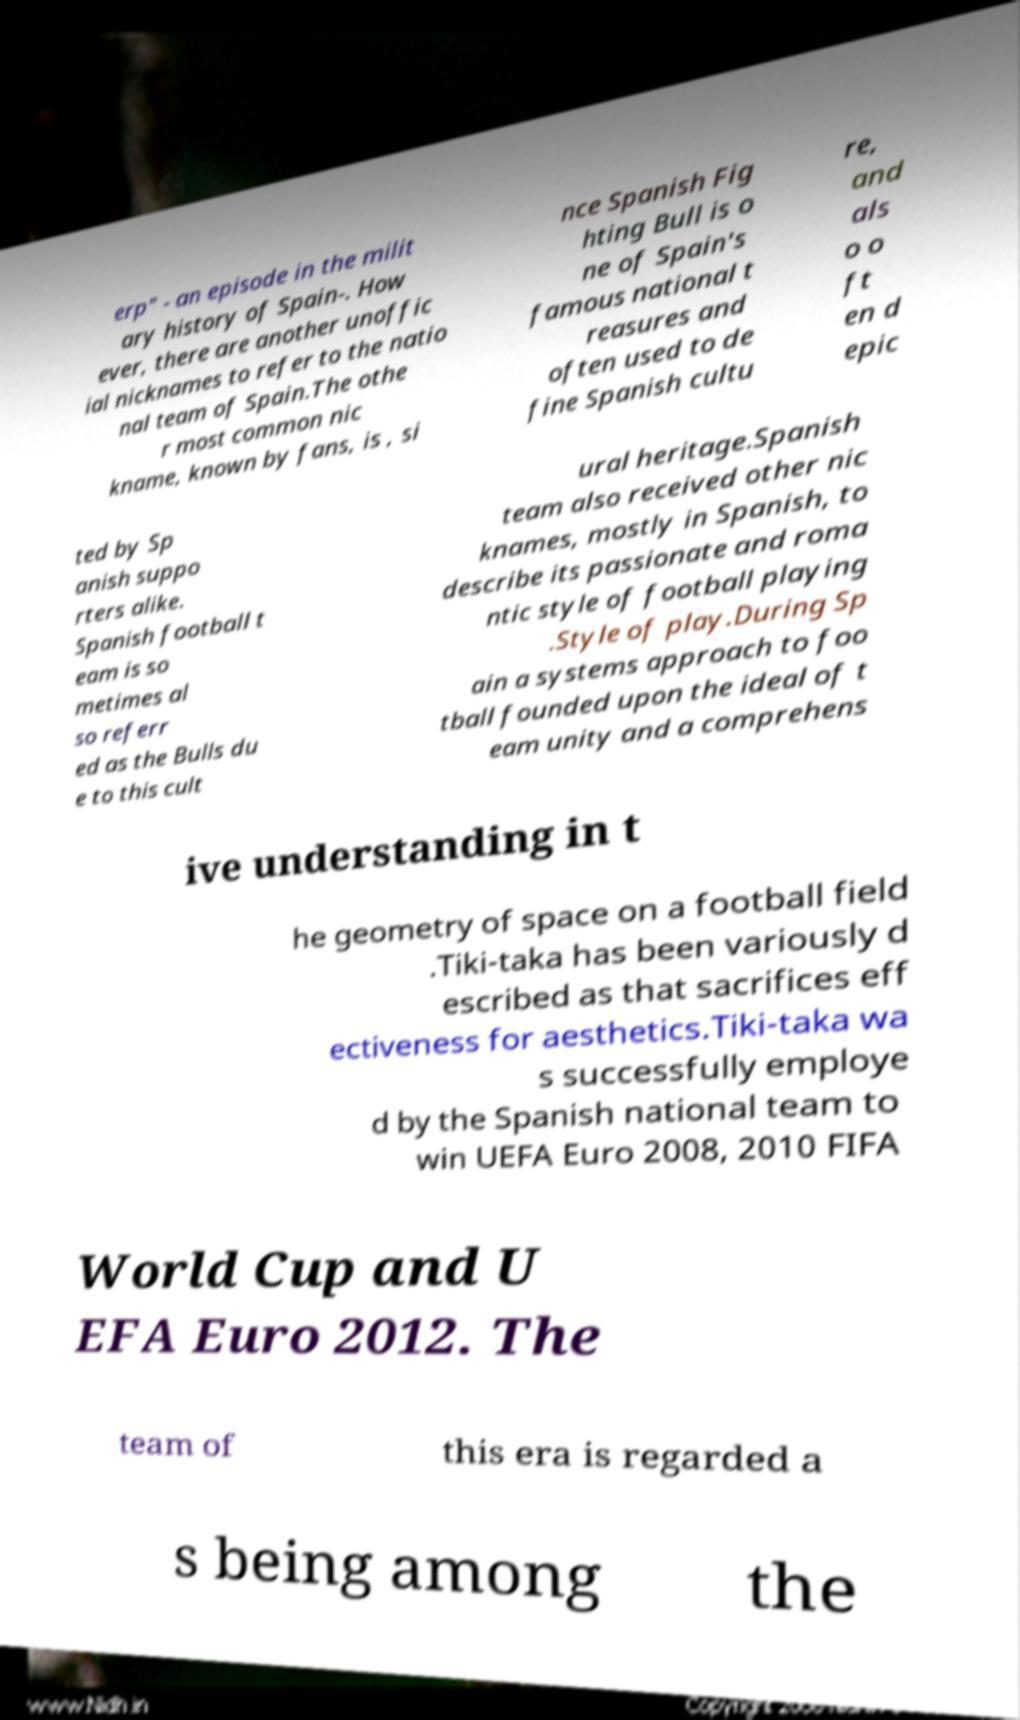Please identify and transcribe the text found in this image. erp" - an episode in the milit ary history of Spain-. How ever, there are another unoffic ial nicknames to refer to the natio nal team of Spain.The othe r most common nic kname, known by fans, is , si nce Spanish Fig hting Bull is o ne of Spain's famous national t reasures and often used to de fine Spanish cultu re, and als o o ft en d epic ted by Sp anish suppo rters alike. Spanish football t eam is so metimes al so referr ed as the Bulls du e to this cult ural heritage.Spanish team also received other nic knames, mostly in Spanish, to describe its passionate and roma ntic style of football playing .Style of play.During Sp ain a systems approach to foo tball founded upon the ideal of t eam unity and a comprehens ive understanding in t he geometry of space on a football field .Tiki-taka has been variously d escribed as that sacrifices eff ectiveness for aesthetics.Tiki-taka wa s successfully employe d by the Spanish national team to win UEFA Euro 2008, 2010 FIFA World Cup and U EFA Euro 2012. The team of this era is regarded a s being among the 